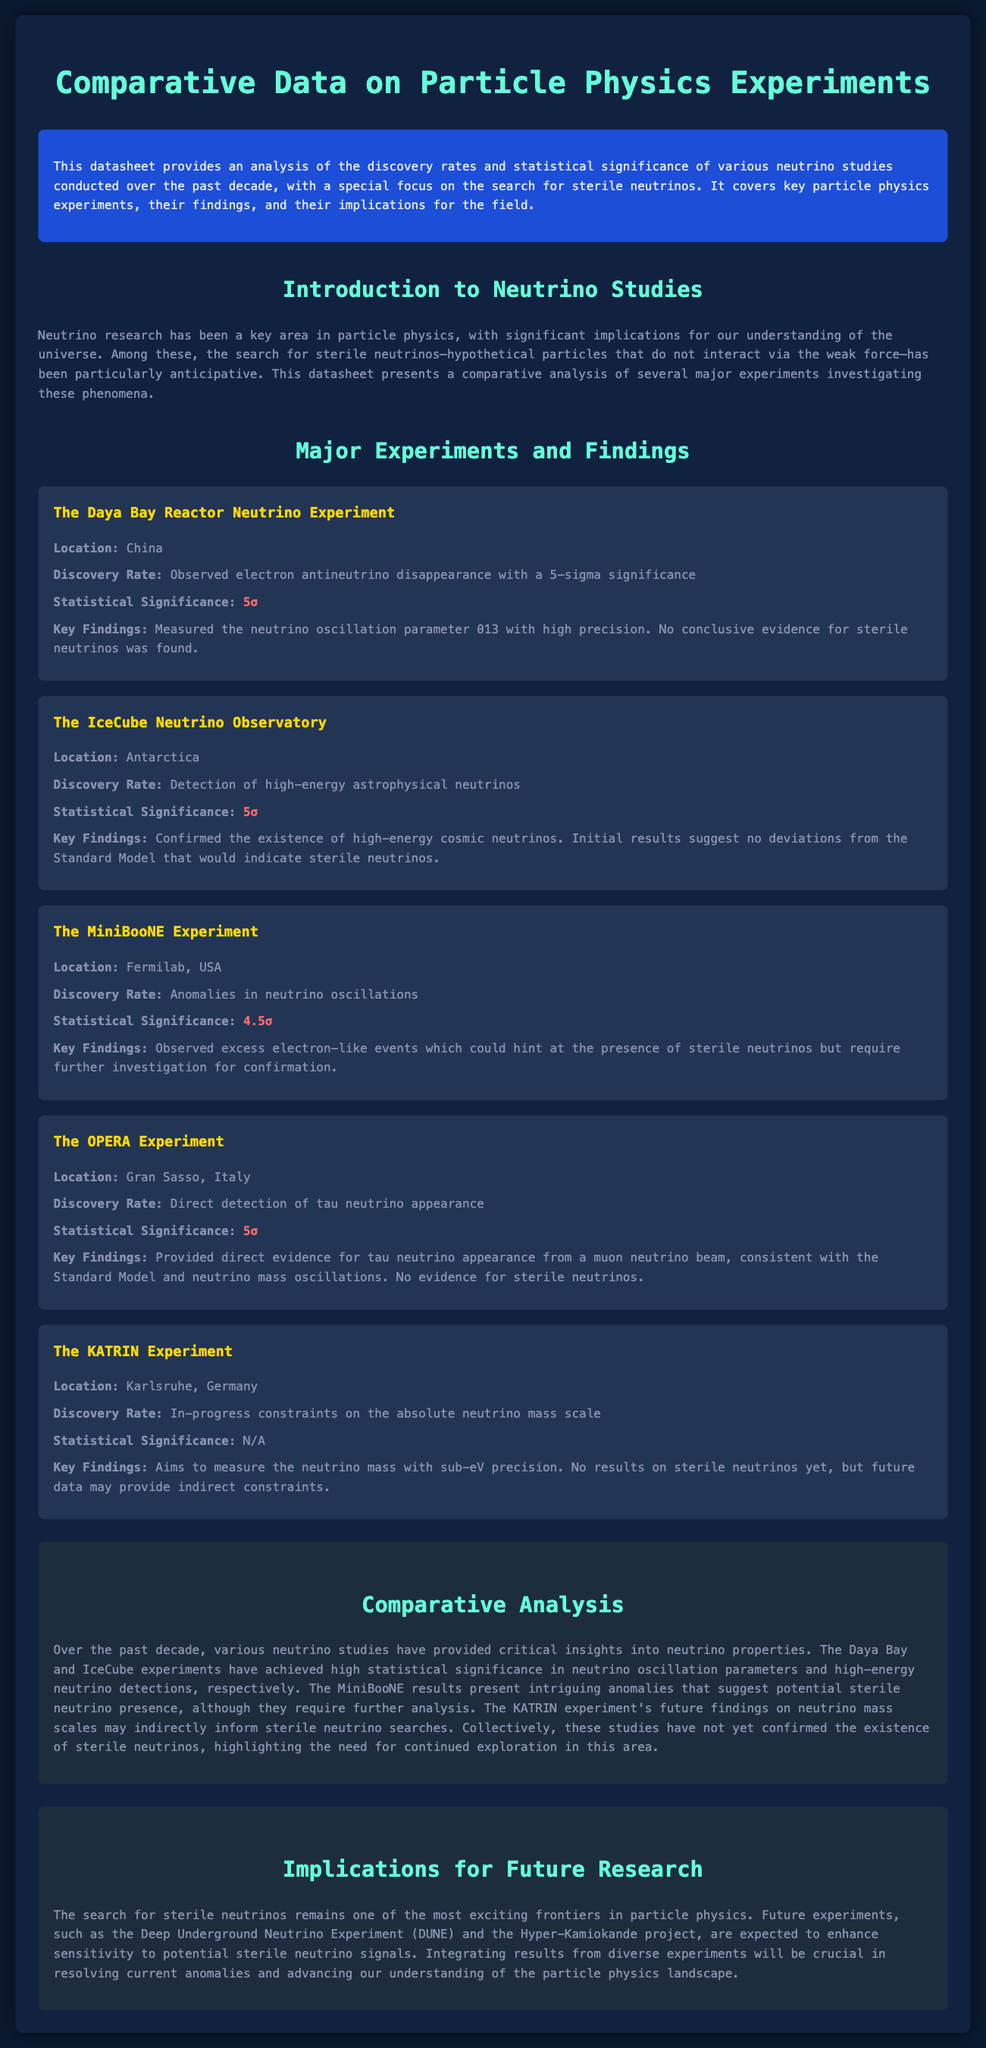What location is associated with the Daya Bay Reactor Neutrino Experiment? The document specifies the location of the Daya Bay Reactor Neutrino Experiment is in China.
Answer: China What is the statistical significance of the IceCube Neutrino Observatory findings? The IceCube Neutrino Observatory has a statistical significance of 5 sigma, as mentioned in the findings.
Answer: 5σ What anomalies were observed in the MiniBooNE Experiment? The MiniBooNE Experiment observed anomalies in neutrino oscillations, requiring further investigation.
Answer: Anomalies in neutrino oscillations What is the discovery rate of the OPERA Experiment? The OPERA Experiment achieved a direct detection of tau neutrino appearance, which is stated in the document.
Answer: Direct detection of tau neutrino appearance Which experiment's findings suggest potential sterile neutrino presence? The findings from the MiniBooNE Experiment suggest potential sterile neutrino presence due to observed excess electron-like events.
Answer: MiniBooNE Experiment What is the overarching focus of this datasheet? The datasheet's primary focus is on the analysis of discovery rates and statistical significance of neutrino studies, particularly sterile neutrinos.
Answer: Sterile neutrinos Which two experiments achieved a 5-sigma significance in their findings? The Daya Bay and IceCube experiments are both highlighted in the document as achieving a 5-sigma significance in their findings.
Answer: Daya Bay and IceCube What type of future research is suggested for sterile neutrinos? The document suggests that future experiments, like DUNE and Hyper-Kamiokande, are planned to enhance sensitivity to potential sterile neutrino signals.
Answer: DUNE and Hyper-Kamiokande 